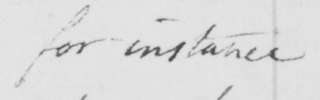Can you read and transcribe this handwriting? for instance 